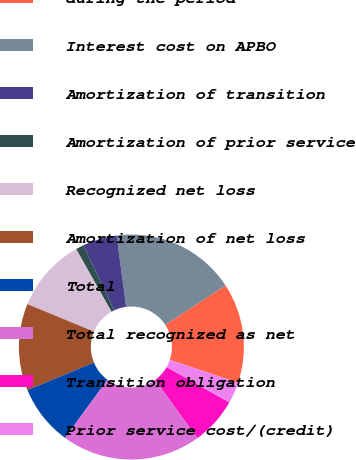Convert chart to OTSL. <chart><loc_0><loc_0><loc_500><loc_500><pie_chart><fcel>during the period<fcel>Interest cost on APBO<fcel>Amortization of transition<fcel>Amortization of prior service<fcel>Recognized net loss<fcel>Amortization of net loss<fcel>Total<fcel>Total recognized as net<fcel>Transition obligation<fcel>Prior service cost/(credit)<nl><fcel>14.37%<fcel>17.86%<fcel>4.93%<fcel>1.16%<fcel>10.59%<fcel>12.48%<fcel>8.71%<fcel>20.03%<fcel>6.82%<fcel>3.05%<nl></chart> 